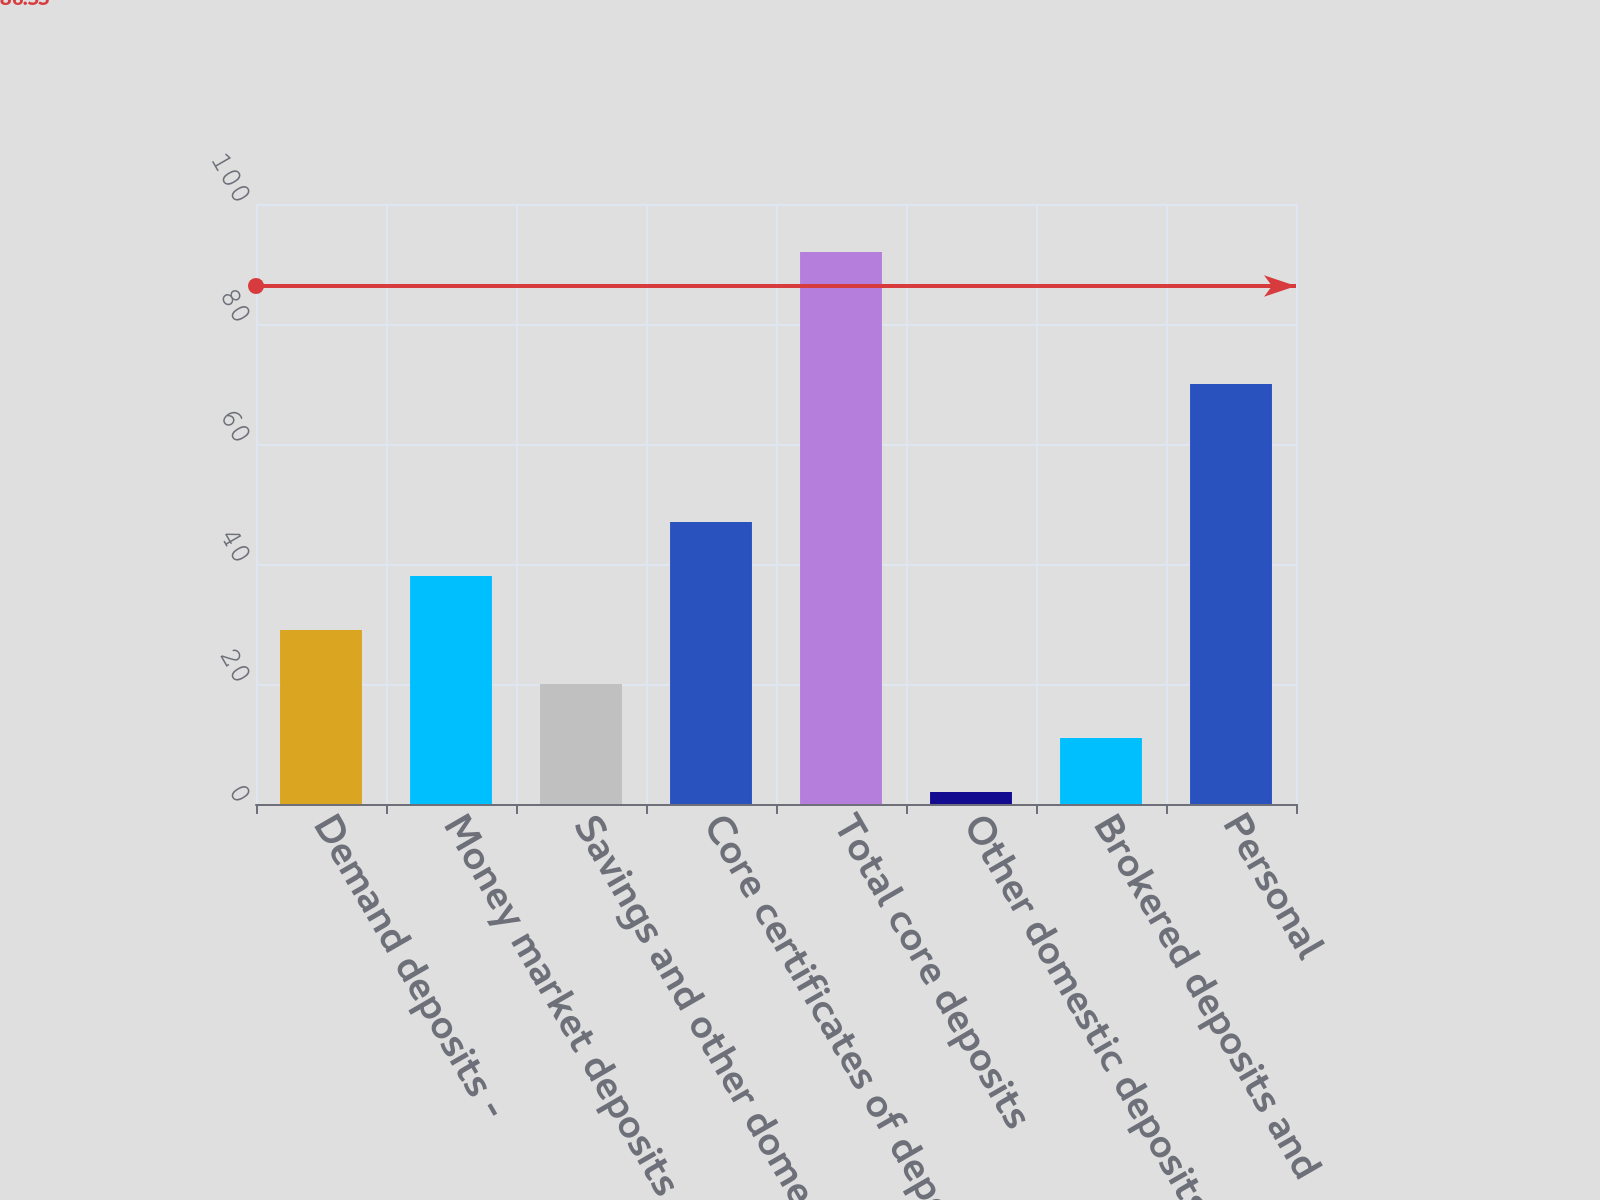<chart> <loc_0><loc_0><loc_500><loc_500><bar_chart><fcel>Demand deposits -<fcel>Money market deposits<fcel>Savings and other domestic<fcel>Core certificates of deposit<fcel>Total core deposits<fcel>Other domestic deposits of<fcel>Brokered deposits and<fcel>Personal<nl><fcel>29<fcel>38<fcel>20<fcel>47<fcel>92<fcel>2<fcel>11<fcel>70<nl></chart> 